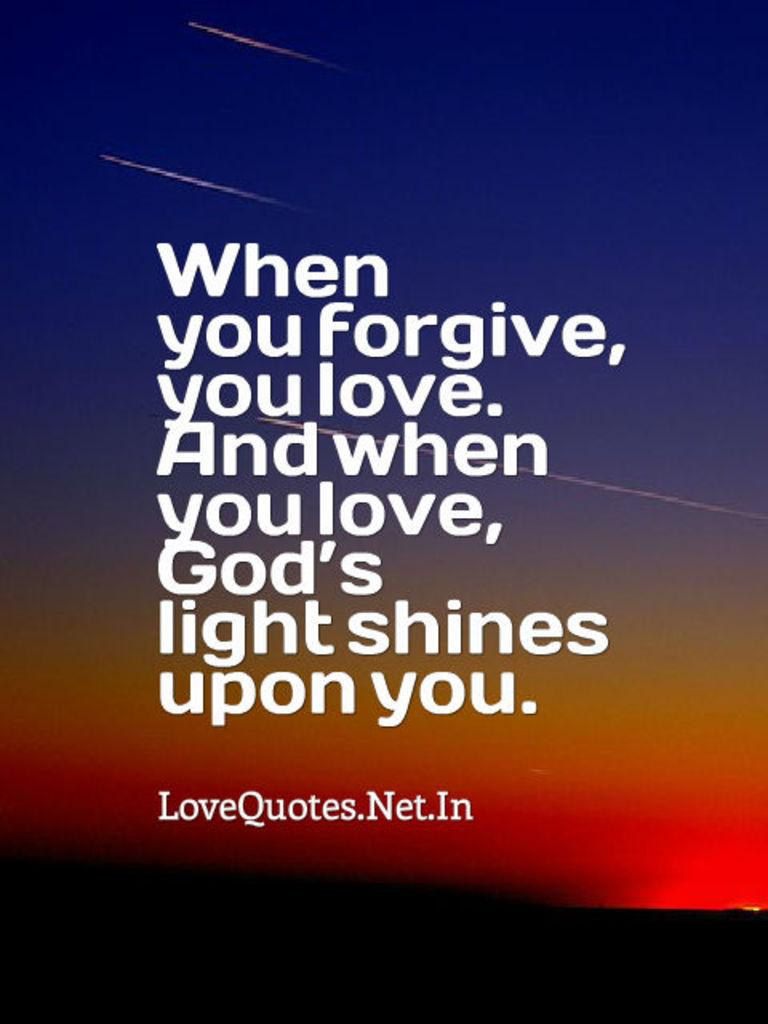<image>
Create a compact narrative representing the image presented. An inspirational poster has the phrase "When you forgive, you love. And when you love, God's light shines upon you" written on it. 